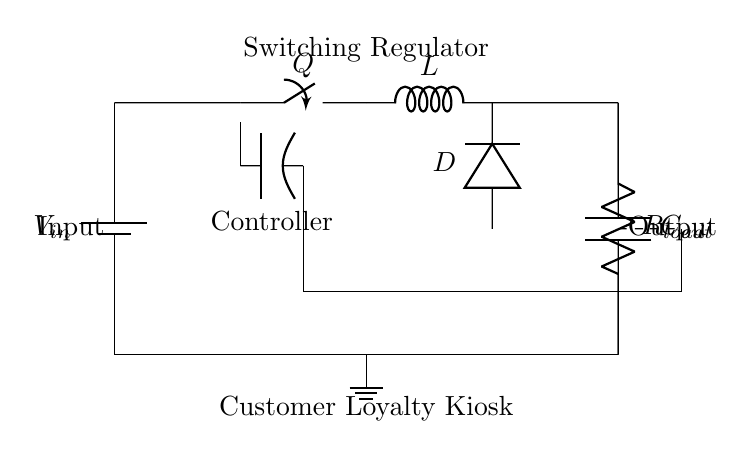What is the input voltage in this circuit? The circuit diagram includes a battery labeled as V_in, which indicates it provides the input voltage to the system.
Answer: V_in What type of switch is used in this regulator? The circuit labeled the component 'Q' as a switch. This indicates that it is a solid-state or mechanical device for switching the circuit on and off.
Answer: Switch Which component stores the output energy? The component labeled as C_out is identified as a capacitor in the circuit, which is used to store energy and smooth out voltage fluctuations at the output.
Answer: Capacitor How many inductors are present in the circuit? The diagram shows only one component marked 'L' for the inductor, which implies that there is a single inductor responsible for energy storage through magnetic fields.
Answer: One What is the role of the diode in this circuit? The diode, labeled as D, allows current to flow in one direction only, protecting against reverse current, particularly important during switching operations in the regulator.
Answer: Prevents reverse current What is the load resistor value in the circuit? The component labeled as R_load is specified as the load resistor. While the exact resistance value is not shown in the diagram, it represents the resistance that the load presents to the circuit.
Answer: R_load What does the dashed line in the circuit represent? The dashed line in the circuit indicates a feedback pathway from the output to the control section, showing that the circuit utilizes feedback for regulation purposes to maintain stable output.
Answer: Feedback 